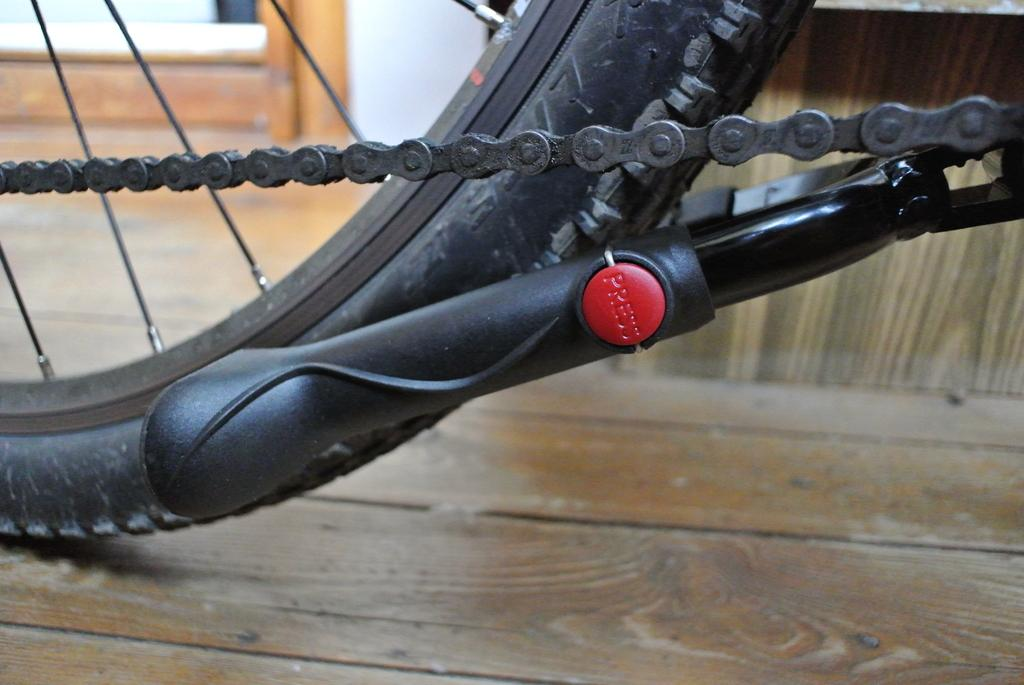What is the main object in the image? There is a bicycle in the image. What is the surface beneath the bicycle? There is a floor visible at the bottom of the image. What can be seen behind the bicycle? There is a wall in the background of the image. What type of hate can be seen on the bicycle in the image? There is no hate present in the image; it is a picture of a bicycle with a floor and a wall in the background. 